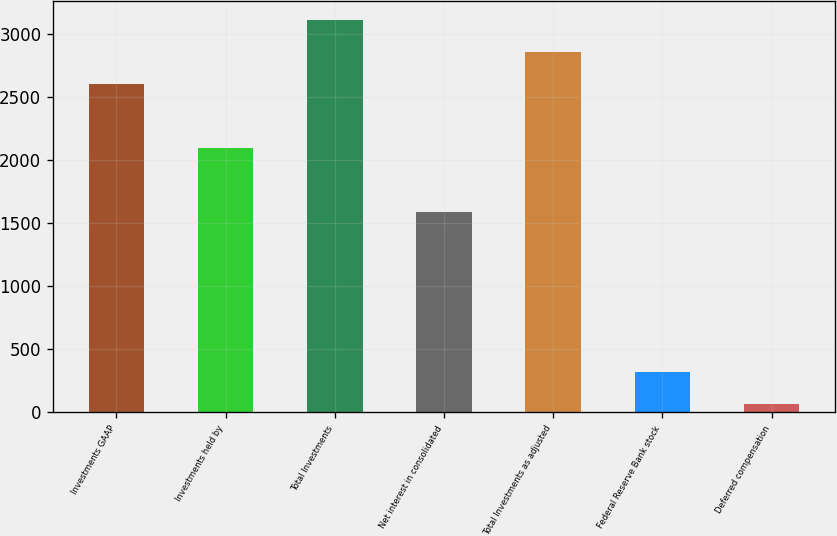Convert chart to OTSL. <chart><loc_0><loc_0><loc_500><loc_500><bar_chart><fcel>Investments GAAP<fcel>Investments held by<fcel>Total Investments<fcel>Net interest in consolidated<fcel>Total Investments as adjusted<fcel>Federal Reserve Bank stock<fcel>Deferred compensation<nl><fcel>2603<fcel>2095.6<fcel>3110.4<fcel>1588.2<fcel>2856.7<fcel>319.7<fcel>66<nl></chart> 